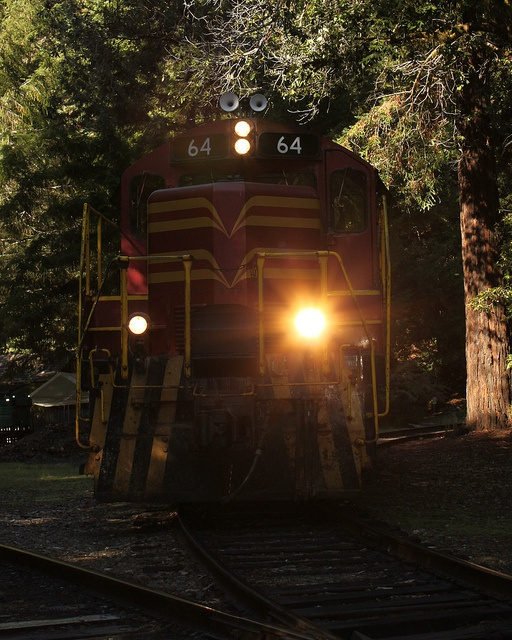Describe the objects in this image and their specific colors. I can see a train in black, maroon, and brown tones in this image. 